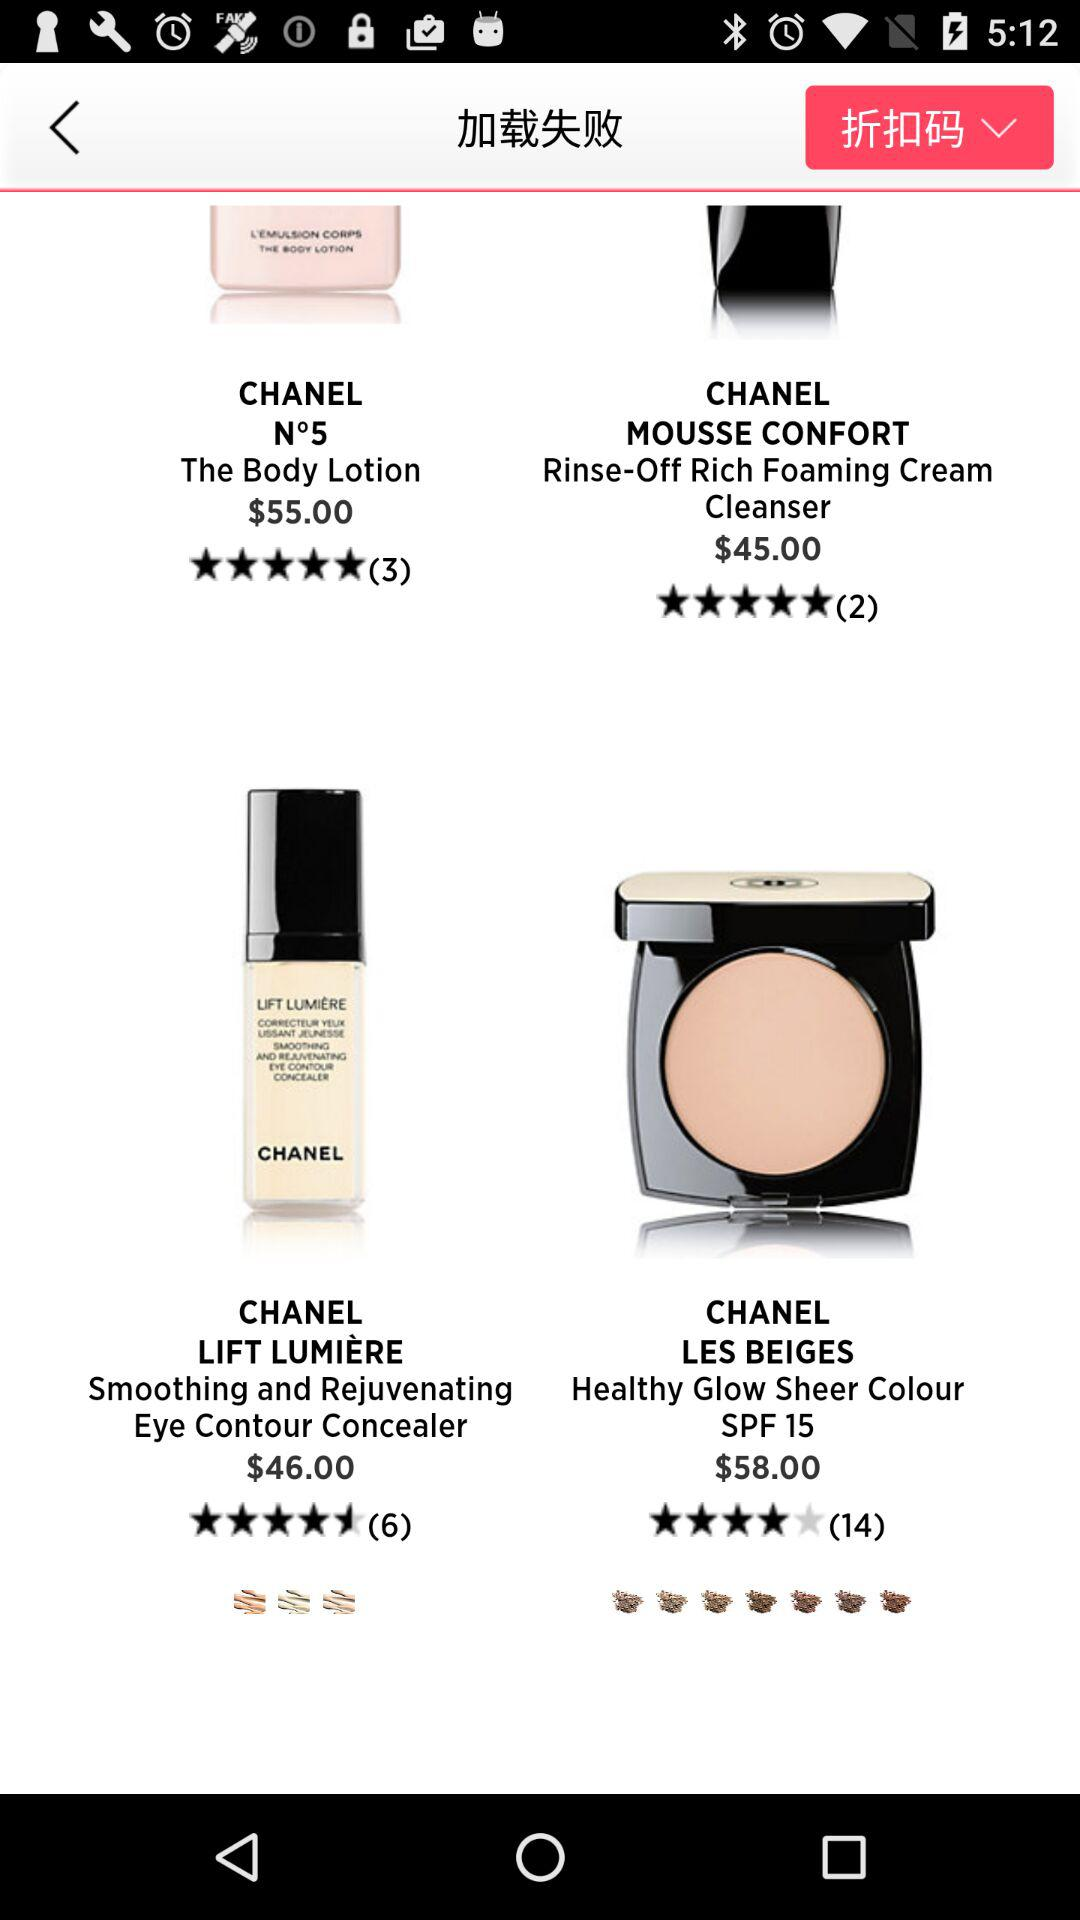What is the rating of "Chanel Mousse Confort Rinse-Off Rich Foaming Cream Cleanser"? The rating is 5 stars. 